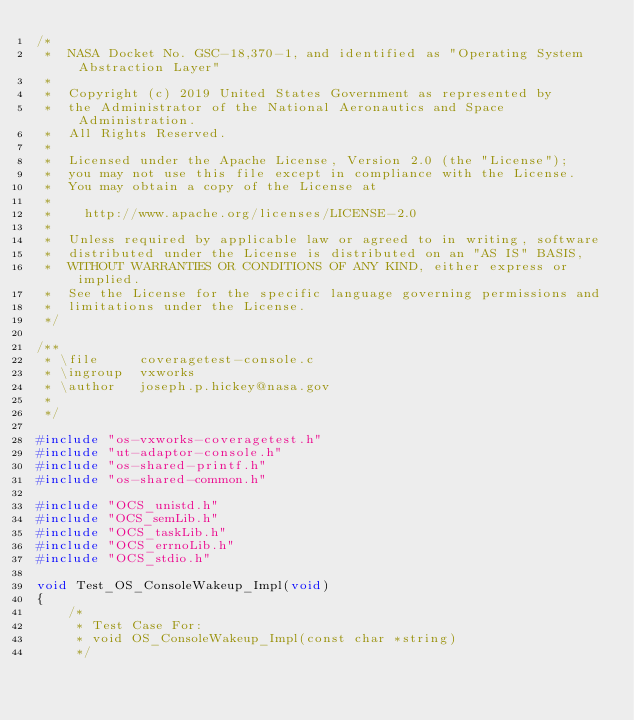Convert code to text. <code><loc_0><loc_0><loc_500><loc_500><_C_>/*
 *  NASA Docket No. GSC-18,370-1, and identified as "Operating System Abstraction Layer"
 *
 *  Copyright (c) 2019 United States Government as represented by
 *  the Administrator of the National Aeronautics and Space Administration.
 *  All Rights Reserved.
 *
 *  Licensed under the Apache License, Version 2.0 (the "License");
 *  you may not use this file except in compliance with the License.
 *  You may obtain a copy of the License at
 *
 *    http://www.apache.org/licenses/LICENSE-2.0
 *
 *  Unless required by applicable law or agreed to in writing, software
 *  distributed under the License is distributed on an "AS IS" BASIS,
 *  WITHOUT WARRANTIES OR CONDITIONS OF ANY KIND, either express or implied.
 *  See the License for the specific language governing permissions and
 *  limitations under the License.
 */

/**
 * \file     coveragetest-console.c
 * \ingroup  vxworks
 * \author   joseph.p.hickey@nasa.gov
 *
 */

#include "os-vxworks-coveragetest.h"
#include "ut-adaptor-console.h"
#include "os-shared-printf.h"
#include "os-shared-common.h"

#include "OCS_unistd.h"
#include "OCS_semLib.h"
#include "OCS_taskLib.h"
#include "OCS_errnoLib.h"
#include "OCS_stdio.h"

void Test_OS_ConsoleWakeup_Impl(void)
{
    /*
     * Test Case For:
     * void OS_ConsoleWakeup_Impl(const char *string)
     */</code> 